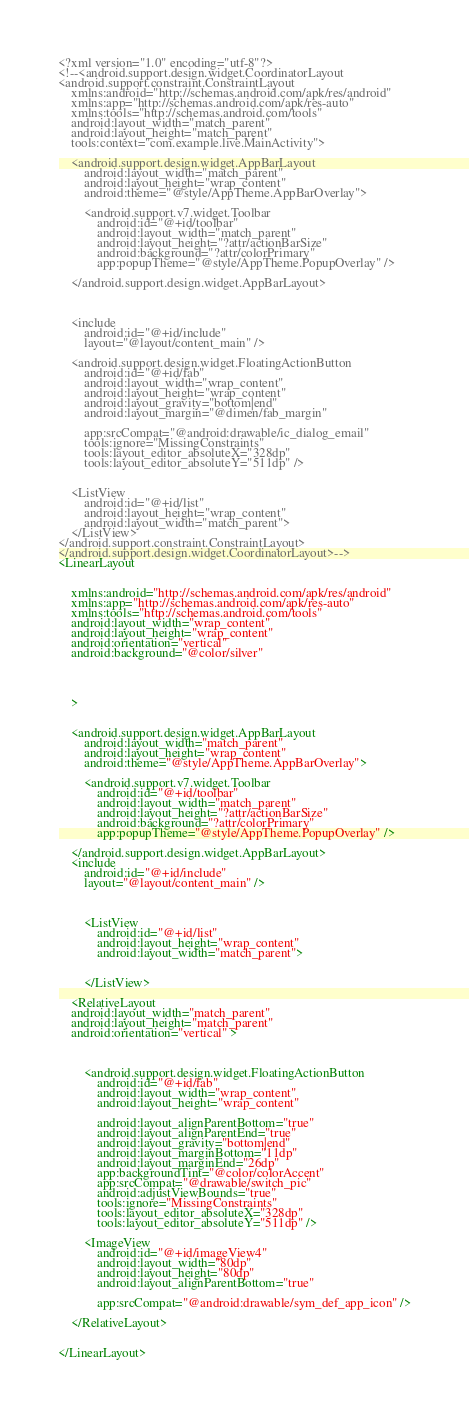<code> <loc_0><loc_0><loc_500><loc_500><_XML_><?xml version="1.0" encoding="utf-8"?>
<!--<android.support.design.widget.CoordinatorLayout
<android.support.constraint.ConstraintLayout
    xmlns:android="http://schemas.android.com/apk/res/android"
    xmlns:app="http://schemas.android.com/apk/res-auto"
    xmlns:tools="http://schemas.android.com/tools"
    android:layout_width="match_parent"
    android:layout_height="match_parent"
    tools:context="com.example.live.MainActivity">

    <android.support.design.widget.AppBarLayout
        android:layout_width="match_parent"
        android:layout_height="wrap_content"
        android:theme="@style/AppTheme.AppBarOverlay">

        <android.support.v7.widget.Toolbar
            android:id="@+id/toolbar"
            android:layout_width="match_parent"
            android:layout_height="?attr/actionBarSize"
            android:background="?attr/colorPrimary"
            app:popupTheme="@style/AppTheme.PopupOverlay" />

    </android.support.design.widget.AppBarLayout>



    <include
        android:id="@+id/include"
        layout="@layout/content_main" />

    <android.support.design.widget.FloatingActionButton
        android:id="@+id/fab"
        android:layout_width="wrap_content"
        android:layout_height="wrap_content"
        android:layout_gravity="bottom|end"
        android:layout_margin="@dimen/fab_margin"

        app:srcCompat="@android:drawable/ic_dialog_email"
        tools:ignore="MissingConstraints"
        tools:layout_editor_absoluteX="328dp"
        tools:layout_editor_absoluteY="511dp" />


    <ListView
        android:id="@+id/list"
        android:layout_height="wrap_content"
        android:layout_width="match_parent">
    </ListView>
</android.support.constraint.ConstraintLayout>
</android.support.design.widget.CoordinatorLayout>-->
<LinearLayout


    xmlns:android="http://schemas.android.com/apk/res/android"
    xmlns:app="http://schemas.android.com/apk/res-auto"
    xmlns:tools="http://schemas.android.com/tools"
    android:layout_width="wrap_content"
    android:layout_height="wrap_content"
    android:orientation="vertical"
    android:background="@color/silver"




    >


    <android.support.design.widget.AppBarLayout
        android:layout_width="match_parent"
        android:layout_height="wrap_content"
        android:theme="@style/AppTheme.AppBarOverlay">

        <android.support.v7.widget.Toolbar
            android:id="@+id/toolbar"
            android:layout_width="match_parent"
            android:layout_height="?attr/actionBarSize"
            android:background="?attr/colorPrimary"
            app:popupTheme="@style/AppTheme.PopupOverlay" />

    </android.support.design.widget.AppBarLayout>
    <include
        android:id="@+id/include"
        layout="@layout/content_main" />



        <ListView
            android:id="@+id/list"
            android:layout_height="wrap_content"
            android:layout_width="match_parent">


        </ListView>

    <RelativeLayout
    android:layout_width="match_parent"
    android:layout_height="match_parent"
    android:orientation="vertical" >



        <android.support.design.widget.FloatingActionButton
            android:id="@+id/fab"
            android:layout_width="wrap_content"
            android:layout_height="wrap_content"

            android:layout_alignParentBottom="true"
            android:layout_alignParentEnd="true"
            android:layout_gravity="bottom|end"
            android:layout_marginBottom="11dp"
            android:layout_marginEnd="26dp"
            app:backgroundTint="@color/colorAccent"
            app:srcCompat="@drawable/switch_pic"
            android:adjustViewBounds="true"
            tools:ignore="MissingConstraints"
            tools:layout_editor_absoluteX="328dp"
            tools:layout_editor_absoluteY="511dp" />

        <ImageView
            android:id="@+id/imageView4"
            android:layout_width="80dp"
            android:layout_height="80dp"
            android:layout_alignParentBottom="true"

            app:srcCompat="@android:drawable/sym_def_app_icon" />

    </RelativeLayout>


</LinearLayout>
</code> 